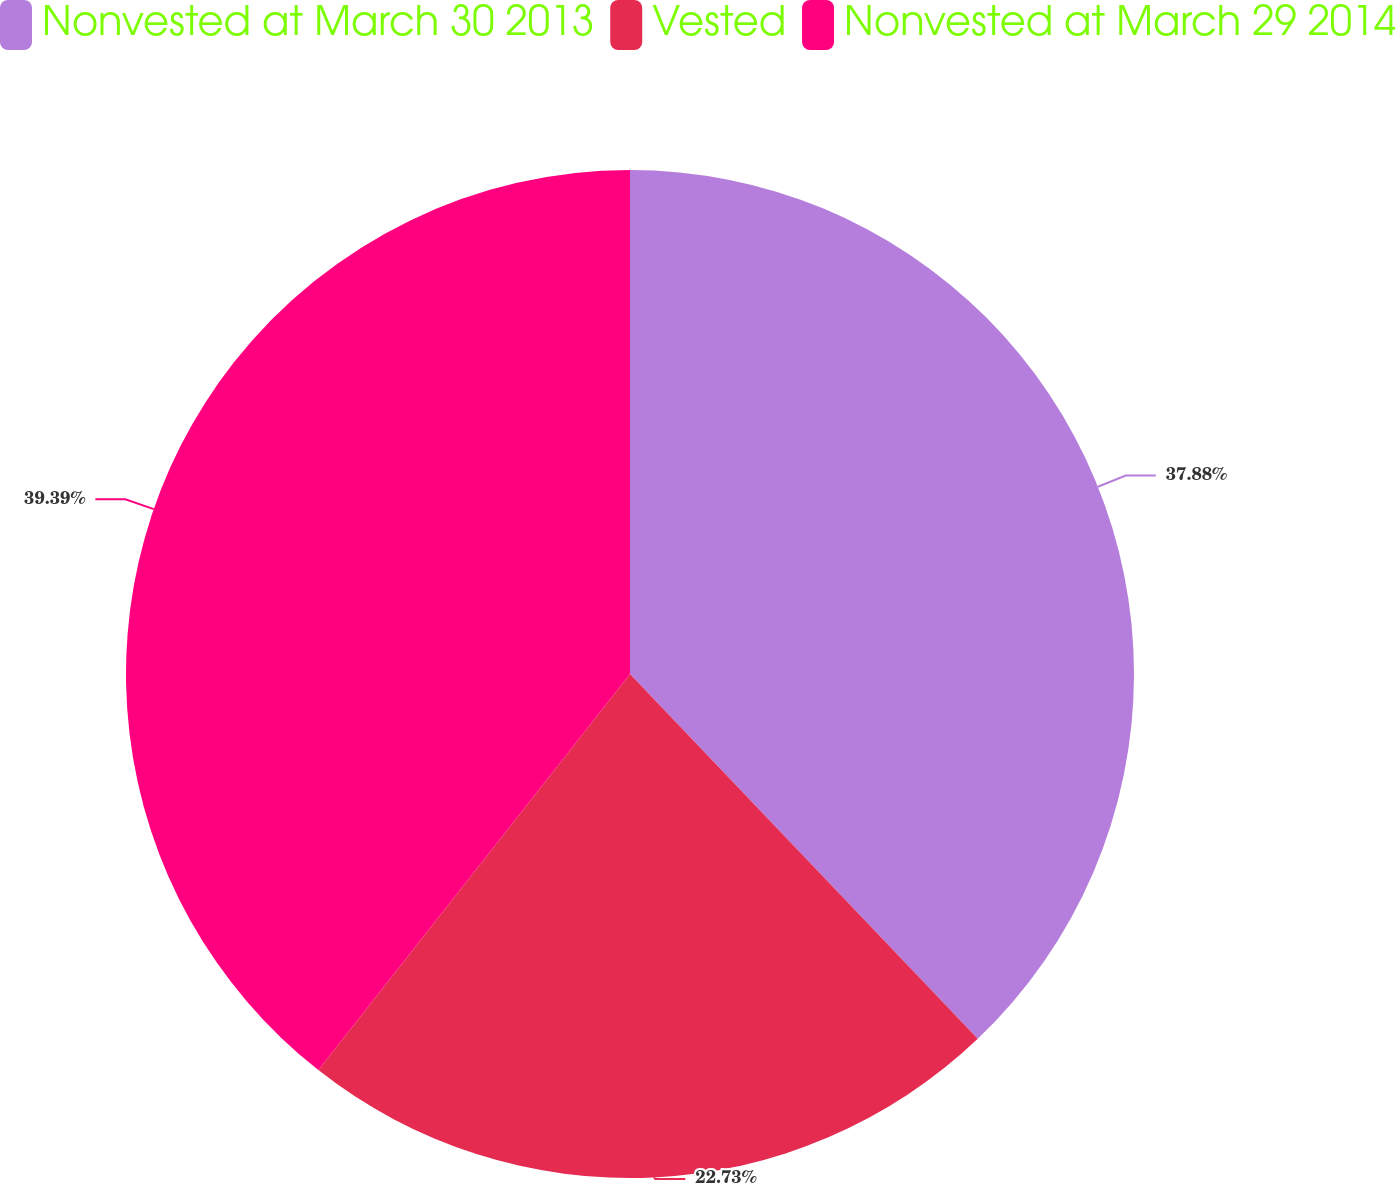Convert chart to OTSL. <chart><loc_0><loc_0><loc_500><loc_500><pie_chart><fcel>Nonvested at March 30 2013<fcel>Vested<fcel>Nonvested at March 29 2014<nl><fcel>37.88%<fcel>22.73%<fcel>39.39%<nl></chart> 